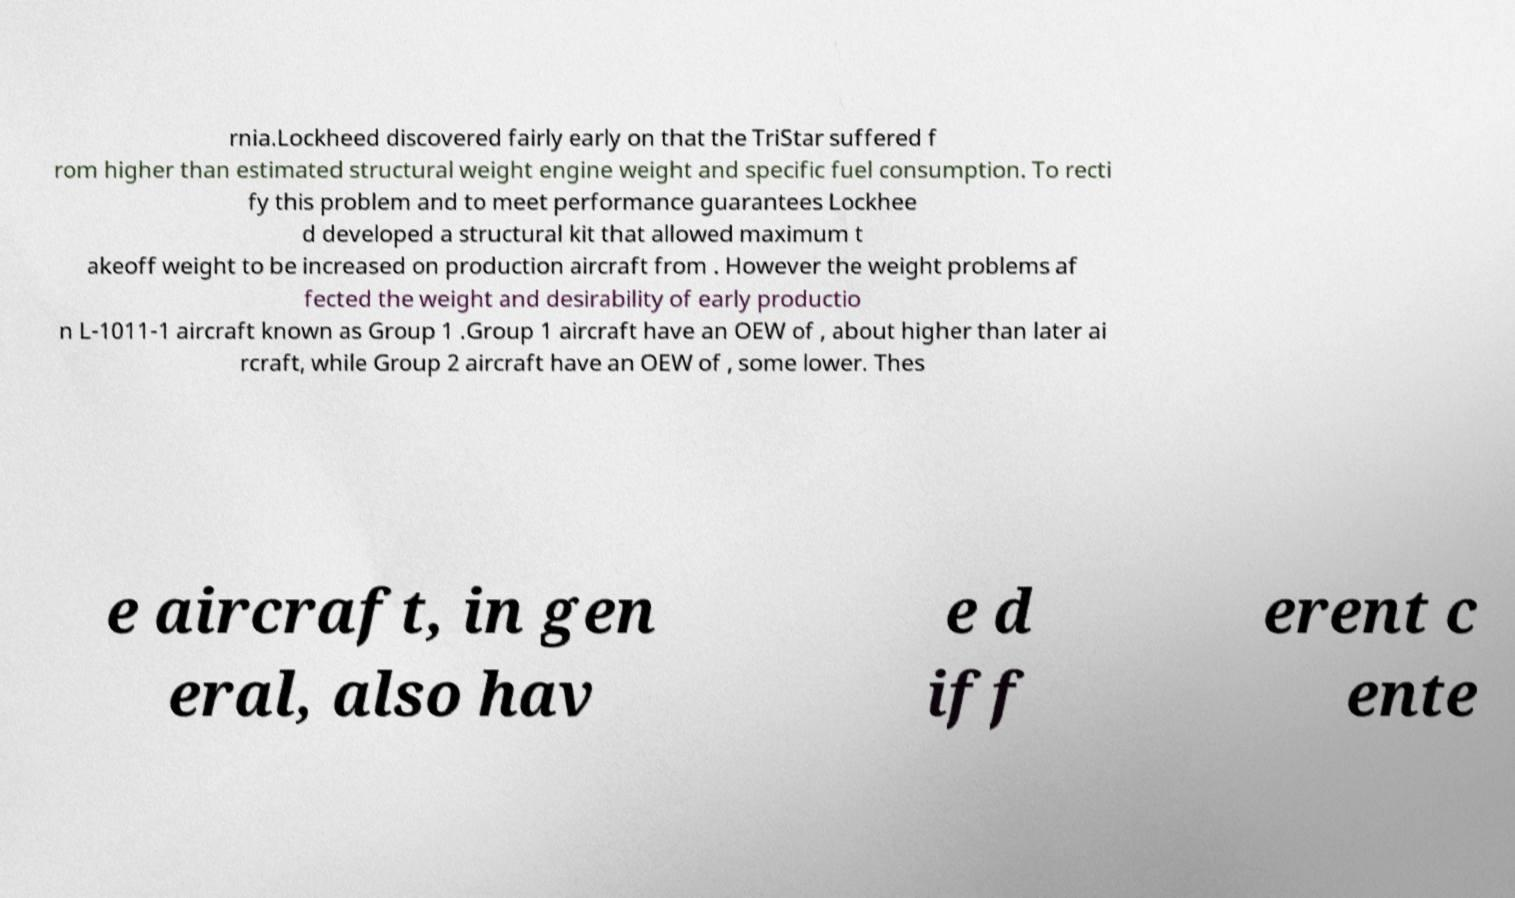Please read and relay the text visible in this image. What does it say? rnia.Lockheed discovered fairly early on that the TriStar suffered f rom higher than estimated structural weight engine weight and specific fuel consumption. To recti fy this problem and to meet performance guarantees Lockhee d developed a structural kit that allowed maximum t akeoff weight to be increased on production aircraft from . However the weight problems af fected the weight and desirability of early productio n L-1011-1 aircraft known as Group 1 .Group 1 aircraft have an OEW of , about higher than later ai rcraft, while Group 2 aircraft have an OEW of , some lower. Thes e aircraft, in gen eral, also hav e d iff erent c ente 